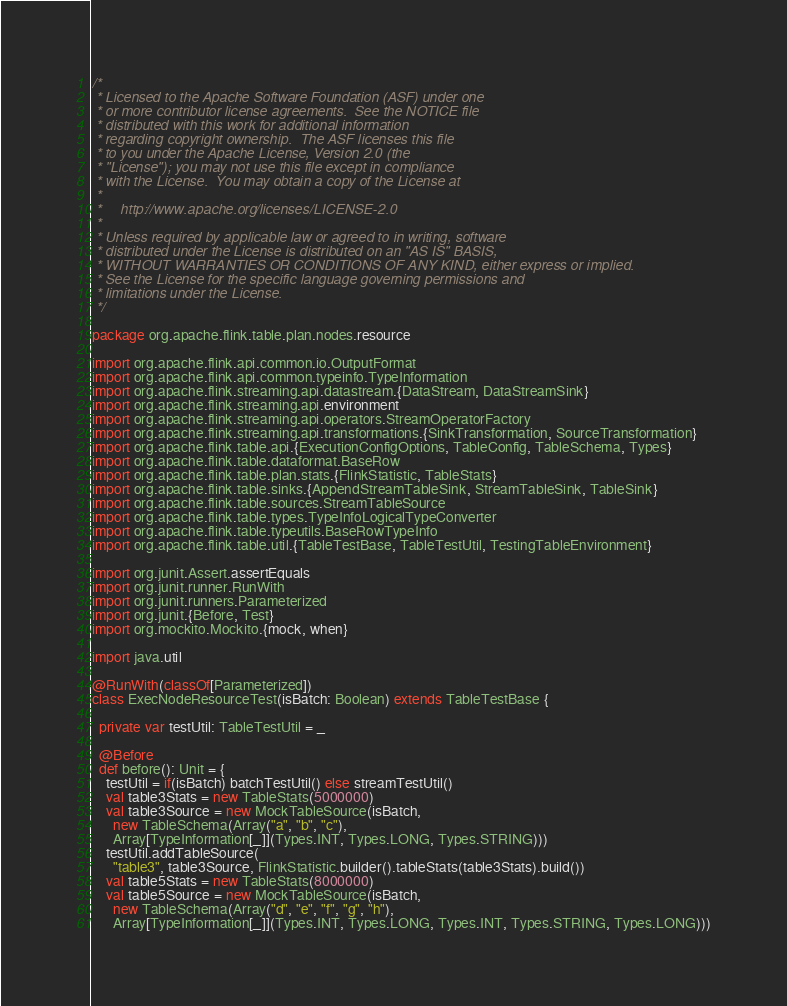<code> <loc_0><loc_0><loc_500><loc_500><_Scala_>/*
 * Licensed to the Apache Software Foundation (ASF) under one
 * or more contributor license agreements.  See the NOTICE file
 * distributed with this work for additional information
 * regarding copyright ownership.  The ASF licenses this file
 * to you under the Apache License, Version 2.0 (the
 * "License"); you may not use this file except in compliance
 * with the License.  You may obtain a copy of the License at
 *
 *     http://www.apache.org/licenses/LICENSE-2.0
 *
 * Unless required by applicable law or agreed to in writing, software
 * distributed under the License is distributed on an "AS IS" BASIS,
 * WITHOUT WARRANTIES OR CONDITIONS OF ANY KIND, either express or implied.
 * See the License for the specific language governing permissions and
 * limitations under the License.
 */

package org.apache.flink.table.plan.nodes.resource

import org.apache.flink.api.common.io.OutputFormat
import org.apache.flink.api.common.typeinfo.TypeInformation
import org.apache.flink.streaming.api.datastream.{DataStream, DataStreamSink}
import org.apache.flink.streaming.api.environment
import org.apache.flink.streaming.api.operators.StreamOperatorFactory
import org.apache.flink.streaming.api.transformations.{SinkTransformation, SourceTransformation}
import org.apache.flink.table.api.{ExecutionConfigOptions, TableConfig, TableSchema, Types}
import org.apache.flink.table.dataformat.BaseRow
import org.apache.flink.table.plan.stats.{FlinkStatistic, TableStats}
import org.apache.flink.table.sinks.{AppendStreamTableSink, StreamTableSink, TableSink}
import org.apache.flink.table.sources.StreamTableSource
import org.apache.flink.table.types.TypeInfoLogicalTypeConverter
import org.apache.flink.table.typeutils.BaseRowTypeInfo
import org.apache.flink.table.util.{TableTestBase, TableTestUtil, TestingTableEnvironment}

import org.junit.Assert.assertEquals
import org.junit.runner.RunWith
import org.junit.runners.Parameterized
import org.junit.{Before, Test}
import org.mockito.Mockito.{mock, when}

import java.util

@RunWith(classOf[Parameterized])
class ExecNodeResourceTest(isBatch: Boolean) extends TableTestBase {

  private var testUtil: TableTestUtil = _

  @Before
  def before(): Unit = {
    testUtil = if(isBatch) batchTestUtil() else streamTestUtil()
    val table3Stats = new TableStats(5000000)
    val table3Source = new MockTableSource(isBatch,
      new TableSchema(Array("a", "b", "c"),
      Array[TypeInformation[_]](Types.INT, Types.LONG, Types.STRING)))
    testUtil.addTableSource(
      "table3", table3Source, FlinkStatistic.builder().tableStats(table3Stats).build())
    val table5Stats = new TableStats(8000000)
    val table5Source = new MockTableSource(isBatch,
      new TableSchema(Array("d", "e", "f", "g", "h"),
      Array[TypeInformation[_]](Types.INT, Types.LONG, Types.INT, Types.STRING, Types.LONG)))</code> 